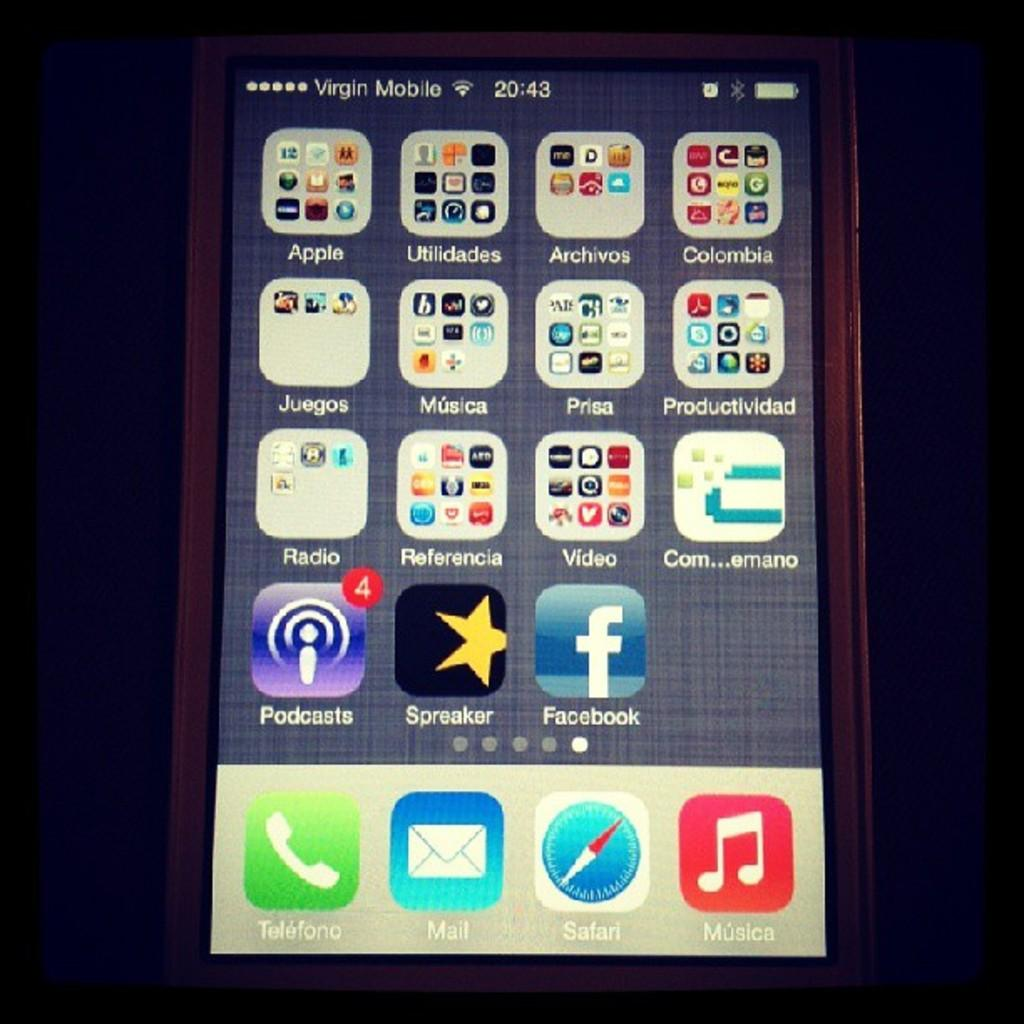<image>
Relay a brief, clear account of the picture shown. A smart phone close up of apps and the podcasts app has 4 notifications. 